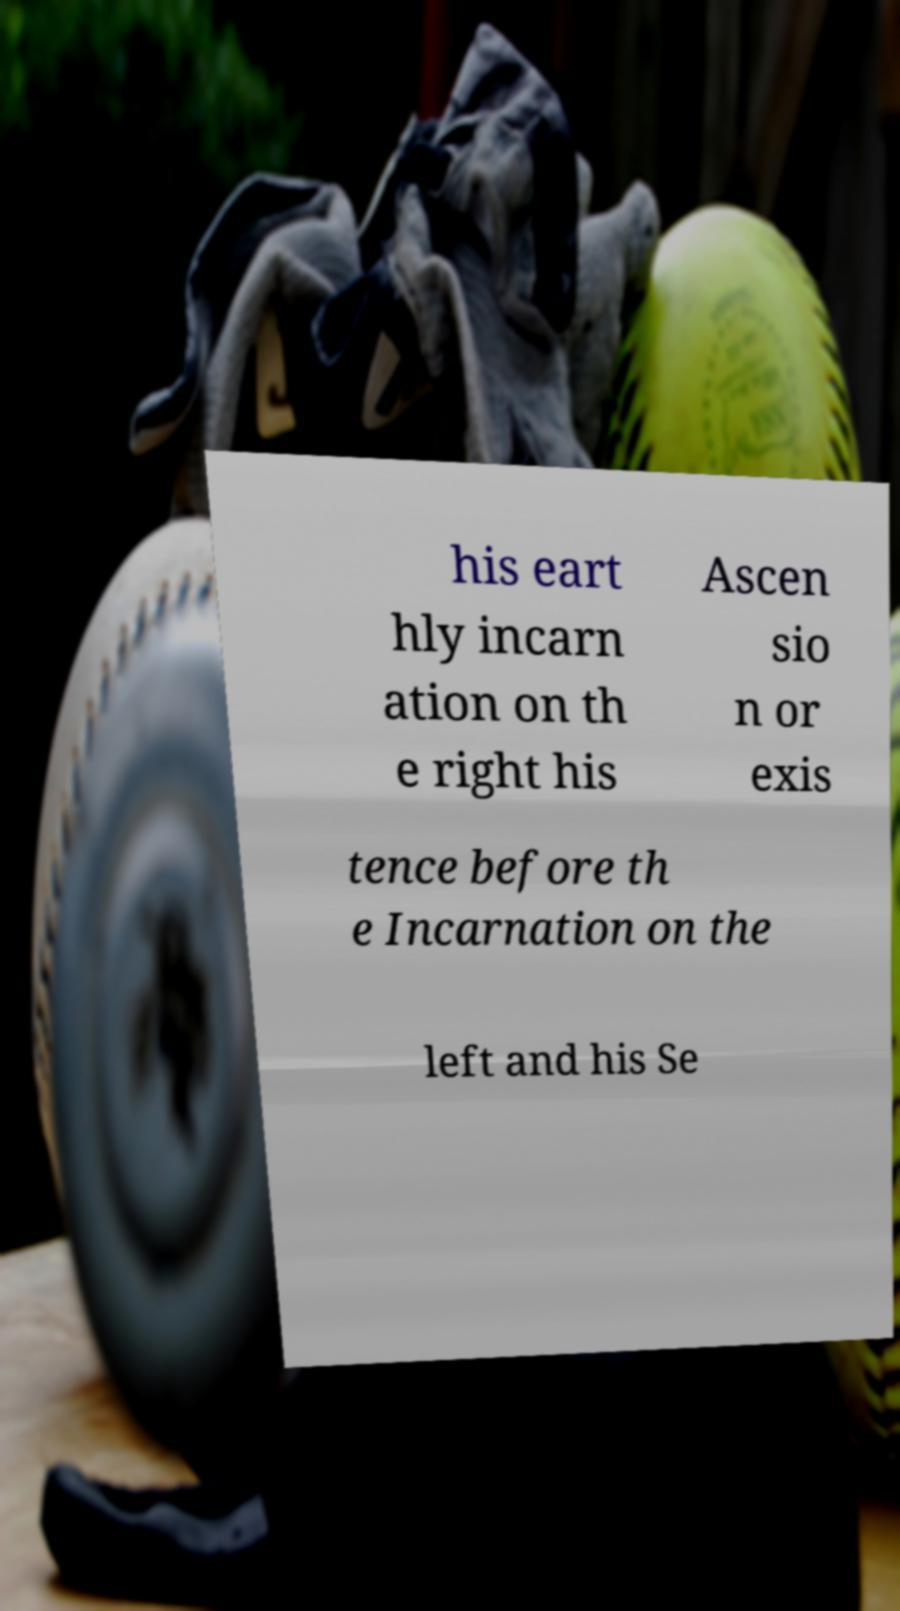What messages or text are displayed in this image? I need them in a readable, typed format. his eart hly incarn ation on th e right his Ascen sio n or exis tence before th e Incarnation on the left and his Se 